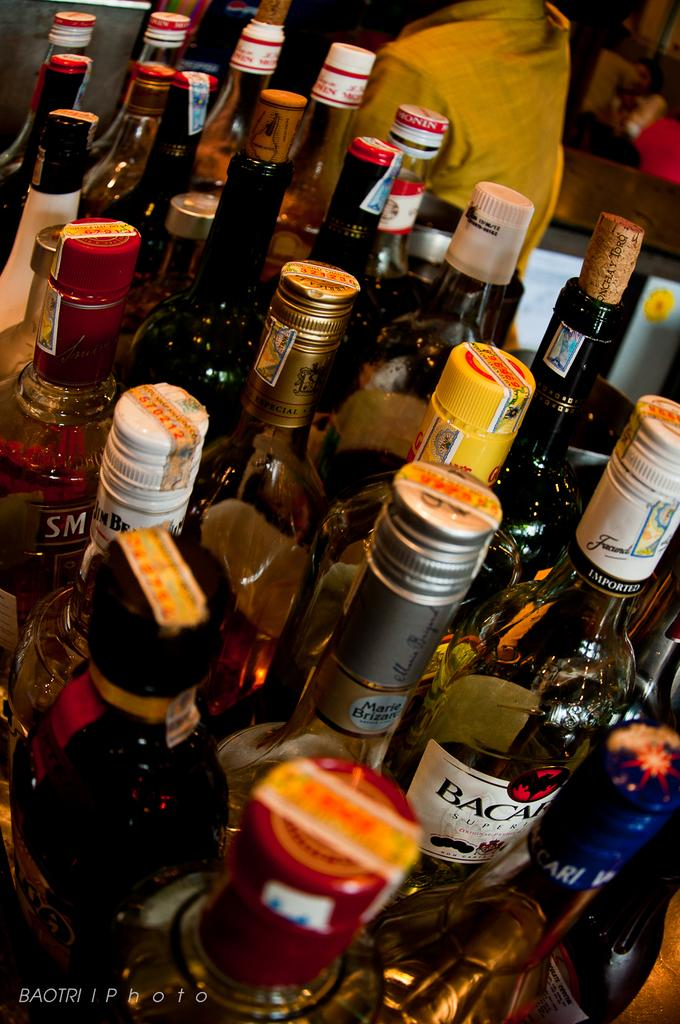<image>
Relay a brief, clear account of the picture shown. A lot of alcohol such as Bacardi are on a table. 